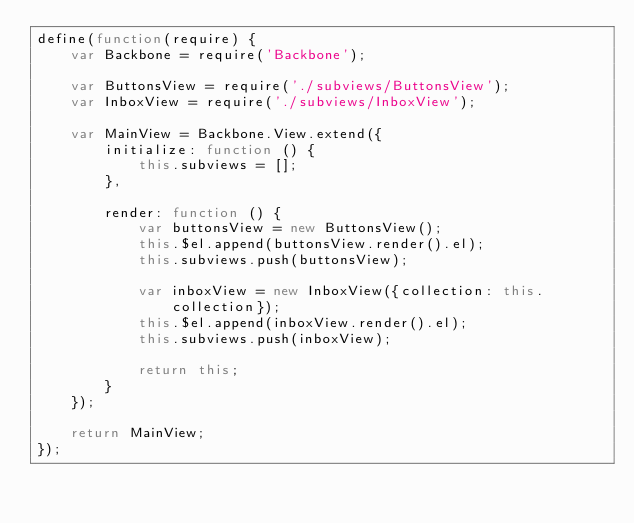<code> <loc_0><loc_0><loc_500><loc_500><_JavaScript_>define(function(require) {
	var Backbone = require('Backbone');

	var ButtonsView = require('./subviews/ButtonsView');
	var InboxView = require('./subviews/InboxView');

	var MainView = Backbone.View.extend({
		initialize: function () {
			this.subviews = [];
		},

		render: function () {
			var buttonsView = new ButtonsView();
			this.$el.append(buttonsView.render().el);
			this.subviews.push(buttonsView);

			var inboxView = new InboxView({collection: this.collection});
			this.$el.append(inboxView.render().el);
			this.subviews.push(inboxView);

			return this;
		}
	});

	return MainView;
});</code> 